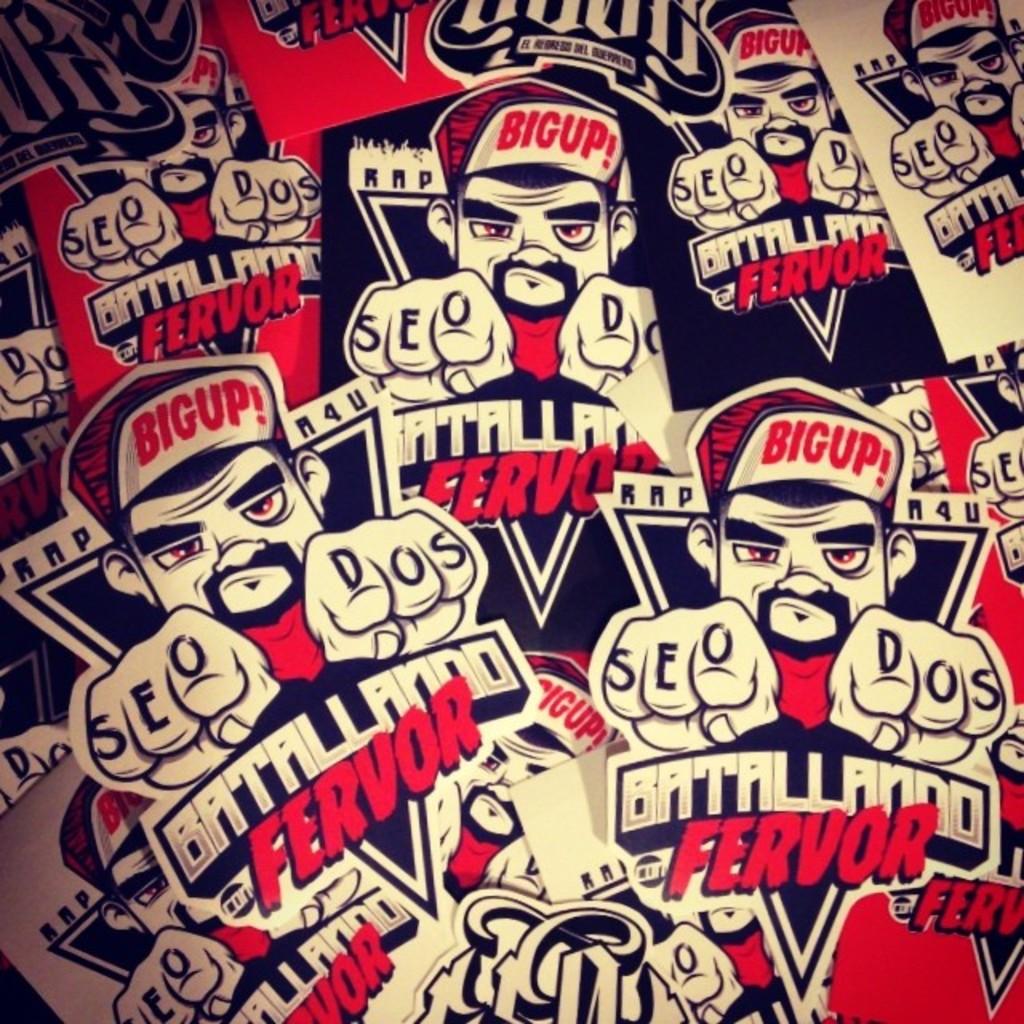What does it say on his cap bill?
Your answer should be compact. Bigup. What is written on his knuckles?
Offer a very short reply. Seo dos. 